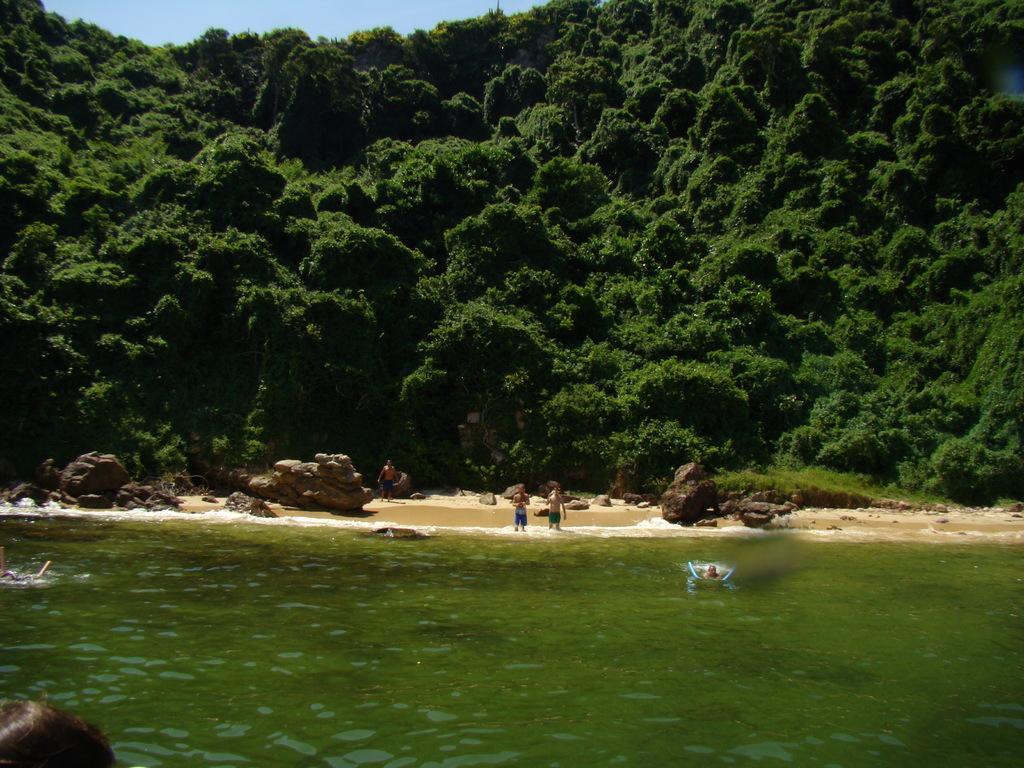Describe this image in one or two sentences. In the image there is a sea and two people were swimming in the water and some other people were standing at the sea shore, around them there are many rocks and in the background there are plenty of trees. 